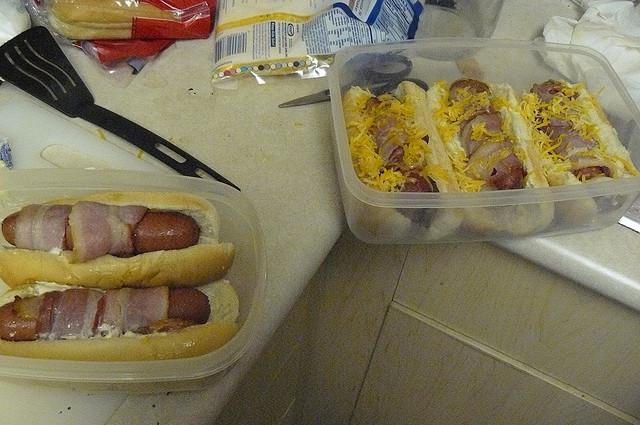Was this prepared at home?
Be succinct. Yes. What is wrapped around these hot dogs?
Answer briefly. Bacon. How many hot dogs are there?
Answer briefly. 5. Is this a healthy meal?
Keep it brief. No. 